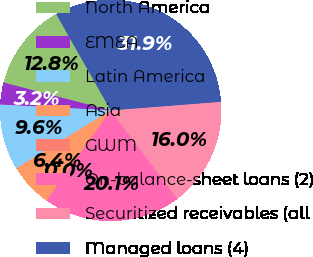<chart> <loc_0><loc_0><loc_500><loc_500><pie_chart><fcel>North America<fcel>EMEA<fcel>Latin America<fcel>Asia<fcel>GWM<fcel>On-balance-sheet loans (2)<fcel>Securitized receivables (all<fcel>Managed loans (4)<nl><fcel>12.78%<fcel>3.2%<fcel>9.59%<fcel>6.4%<fcel>0.01%<fcel>20.1%<fcel>15.97%<fcel>31.94%<nl></chart> 